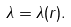<formula> <loc_0><loc_0><loc_500><loc_500>\lambda = \lambda ( r ) .</formula> 